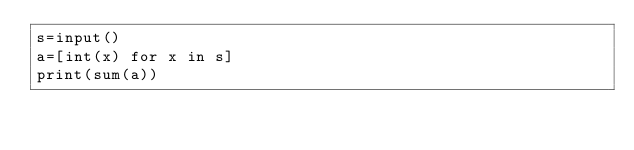<code> <loc_0><loc_0><loc_500><loc_500><_Python_>s=input()
a=[int(x) for x in s]
print(sum(a))</code> 